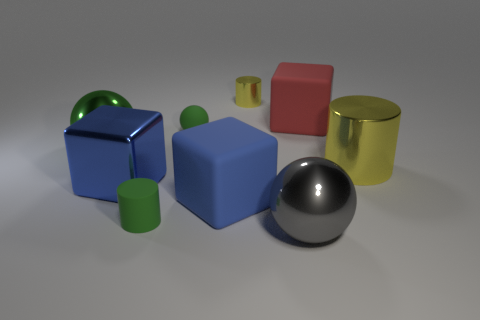Subtract all green spheres. Subtract all green blocks. How many spheres are left? 1 Subtract all cylinders. How many objects are left? 6 Add 8 big green objects. How many big green objects are left? 9 Add 7 blue shiny things. How many blue shiny things exist? 8 Subtract 0 purple balls. How many objects are left? 9 Subtract all green matte cylinders. Subtract all big blue matte objects. How many objects are left? 7 